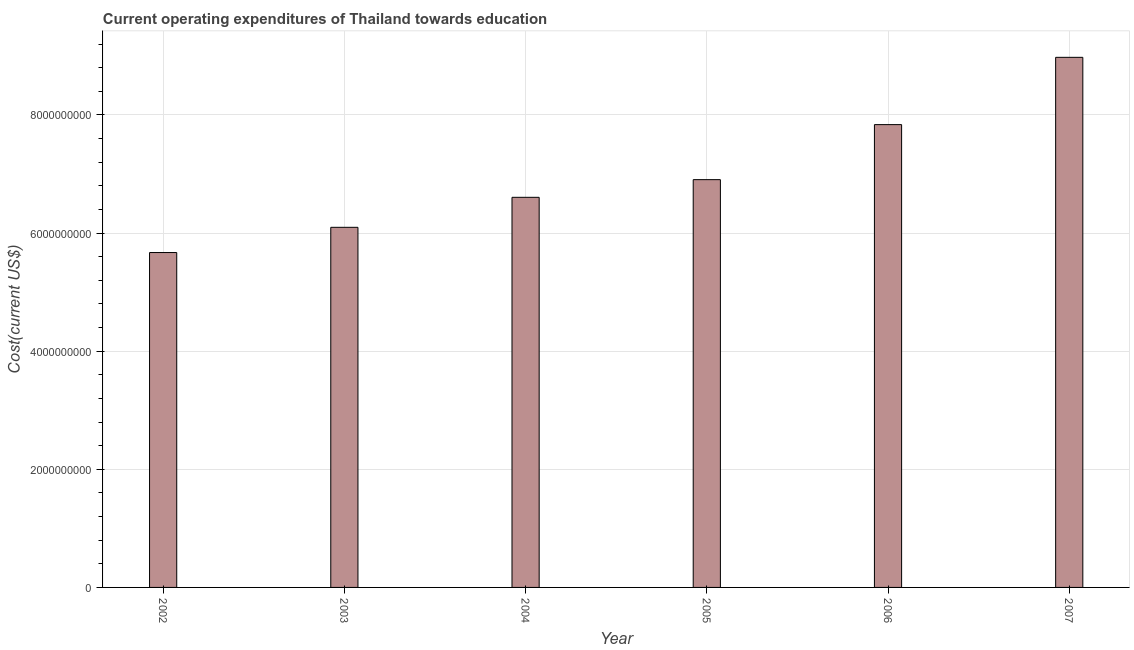Does the graph contain any zero values?
Provide a short and direct response. No. What is the title of the graph?
Give a very brief answer. Current operating expenditures of Thailand towards education. What is the label or title of the X-axis?
Offer a very short reply. Year. What is the label or title of the Y-axis?
Provide a succinct answer. Cost(current US$). What is the education expenditure in 2002?
Offer a terse response. 5.67e+09. Across all years, what is the maximum education expenditure?
Provide a short and direct response. 8.97e+09. Across all years, what is the minimum education expenditure?
Provide a succinct answer. 5.67e+09. In which year was the education expenditure maximum?
Give a very brief answer. 2007. What is the sum of the education expenditure?
Keep it short and to the point. 4.21e+1. What is the difference between the education expenditure in 2004 and 2006?
Your answer should be very brief. -1.23e+09. What is the average education expenditure per year?
Ensure brevity in your answer.  7.01e+09. What is the median education expenditure?
Offer a terse response. 6.75e+09. In how many years, is the education expenditure greater than 8400000000 US$?
Keep it short and to the point. 1. What is the ratio of the education expenditure in 2002 to that in 2004?
Ensure brevity in your answer.  0.86. Is the difference between the education expenditure in 2002 and 2003 greater than the difference between any two years?
Your answer should be compact. No. What is the difference between the highest and the second highest education expenditure?
Provide a short and direct response. 1.14e+09. What is the difference between the highest and the lowest education expenditure?
Your response must be concise. 3.30e+09. What is the Cost(current US$) in 2002?
Provide a short and direct response. 5.67e+09. What is the Cost(current US$) of 2003?
Your response must be concise. 6.10e+09. What is the Cost(current US$) in 2004?
Provide a short and direct response. 6.60e+09. What is the Cost(current US$) in 2005?
Offer a terse response. 6.90e+09. What is the Cost(current US$) in 2006?
Your answer should be very brief. 7.84e+09. What is the Cost(current US$) in 2007?
Offer a terse response. 8.97e+09. What is the difference between the Cost(current US$) in 2002 and 2003?
Offer a terse response. -4.27e+08. What is the difference between the Cost(current US$) in 2002 and 2004?
Keep it short and to the point. -9.35e+08. What is the difference between the Cost(current US$) in 2002 and 2005?
Ensure brevity in your answer.  -1.23e+09. What is the difference between the Cost(current US$) in 2002 and 2006?
Make the answer very short. -2.17e+09. What is the difference between the Cost(current US$) in 2002 and 2007?
Your answer should be compact. -3.30e+09. What is the difference between the Cost(current US$) in 2003 and 2004?
Make the answer very short. -5.08e+08. What is the difference between the Cost(current US$) in 2003 and 2005?
Give a very brief answer. -8.07e+08. What is the difference between the Cost(current US$) in 2003 and 2006?
Provide a succinct answer. -1.74e+09. What is the difference between the Cost(current US$) in 2003 and 2007?
Provide a succinct answer. -2.88e+09. What is the difference between the Cost(current US$) in 2004 and 2005?
Your response must be concise. -2.99e+08. What is the difference between the Cost(current US$) in 2004 and 2006?
Your answer should be compact. -1.23e+09. What is the difference between the Cost(current US$) in 2004 and 2007?
Keep it short and to the point. -2.37e+09. What is the difference between the Cost(current US$) in 2005 and 2006?
Your response must be concise. -9.32e+08. What is the difference between the Cost(current US$) in 2005 and 2007?
Your answer should be very brief. -2.07e+09. What is the difference between the Cost(current US$) in 2006 and 2007?
Give a very brief answer. -1.14e+09. What is the ratio of the Cost(current US$) in 2002 to that in 2004?
Give a very brief answer. 0.86. What is the ratio of the Cost(current US$) in 2002 to that in 2005?
Provide a succinct answer. 0.82. What is the ratio of the Cost(current US$) in 2002 to that in 2006?
Provide a short and direct response. 0.72. What is the ratio of the Cost(current US$) in 2002 to that in 2007?
Give a very brief answer. 0.63. What is the ratio of the Cost(current US$) in 2003 to that in 2004?
Make the answer very short. 0.92. What is the ratio of the Cost(current US$) in 2003 to that in 2005?
Ensure brevity in your answer.  0.88. What is the ratio of the Cost(current US$) in 2003 to that in 2006?
Offer a very short reply. 0.78. What is the ratio of the Cost(current US$) in 2003 to that in 2007?
Give a very brief answer. 0.68. What is the ratio of the Cost(current US$) in 2004 to that in 2006?
Provide a short and direct response. 0.84. What is the ratio of the Cost(current US$) in 2004 to that in 2007?
Your answer should be compact. 0.74. What is the ratio of the Cost(current US$) in 2005 to that in 2006?
Give a very brief answer. 0.88. What is the ratio of the Cost(current US$) in 2005 to that in 2007?
Your answer should be very brief. 0.77. What is the ratio of the Cost(current US$) in 2006 to that in 2007?
Keep it short and to the point. 0.87. 